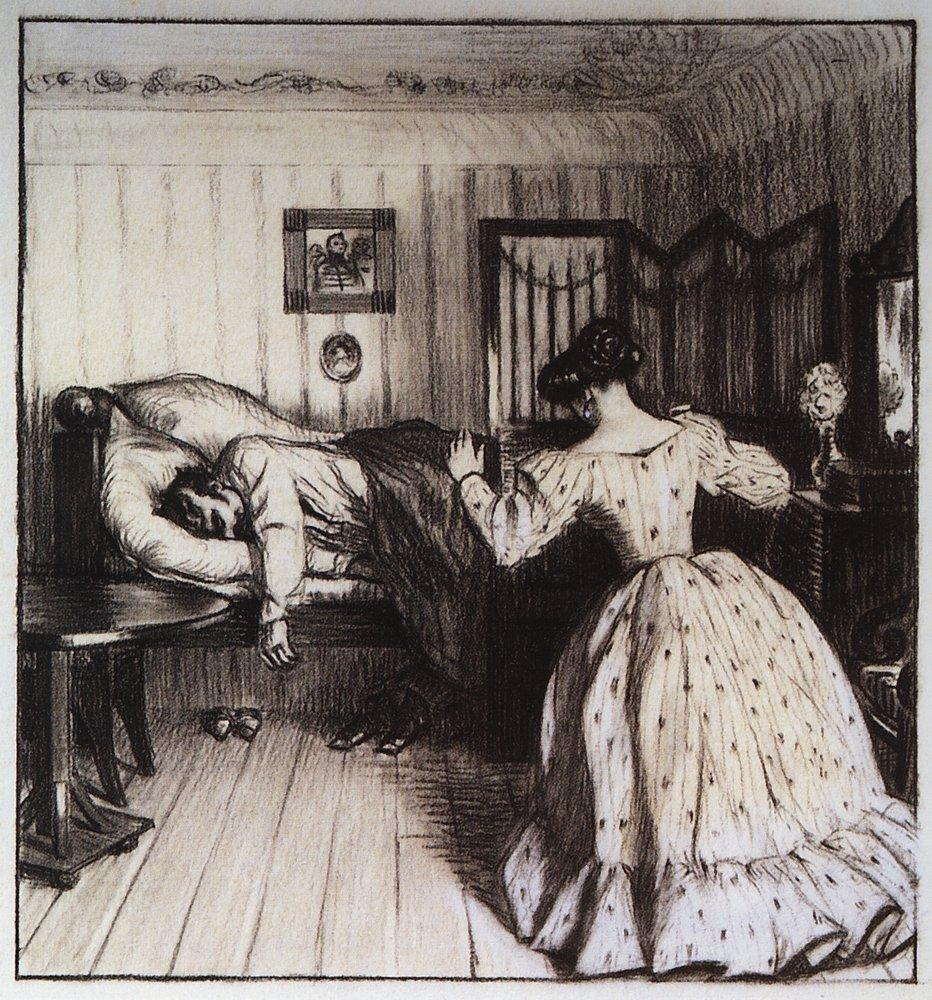What might the woman be reading, and how does it contribute to the scene's atmosphere? The woman might be engrossed in a novel or poetry, common literary forms that were admired in the depicted era. Her reading adds a layer of intellectual pursuit and tranquility to the scene, emphasizing a quiet moment of personal development and cultural engagement, which contrasts with the stillness of the man's rest, highlighting a dynamic yet peaceful coexistence within the room. 